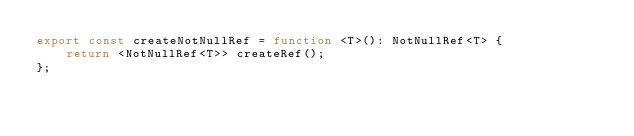<code> <loc_0><loc_0><loc_500><loc_500><_TypeScript_>export const createNotNullRef = function <T>(): NotNullRef<T> {
    return <NotNullRef<T>> createRef();
};</code> 